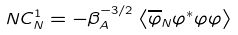<formula> <loc_0><loc_0><loc_500><loc_500>N C _ { N } ^ { 1 } = - \beta _ { A } ^ { - 3 / 2 } \left \langle \overline { \varphi } _ { N } \varphi ^ { \ast } \varphi \varphi \right \rangle</formula> 